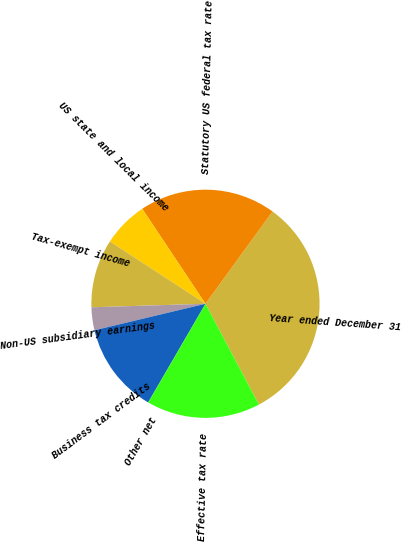Convert chart. <chart><loc_0><loc_0><loc_500><loc_500><pie_chart><fcel>Year ended December 31<fcel>Statutory US federal tax rate<fcel>US state and local income<fcel>Tax-exempt income<fcel>Non-US subsidiary earnings<fcel>Business tax credits<fcel>Other net<fcel>Effective tax rate<nl><fcel>32.24%<fcel>19.35%<fcel>6.46%<fcel>9.68%<fcel>3.24%<fcel>12.9%<fcel>0.01%<fcel>16.12%<nl></chart> 